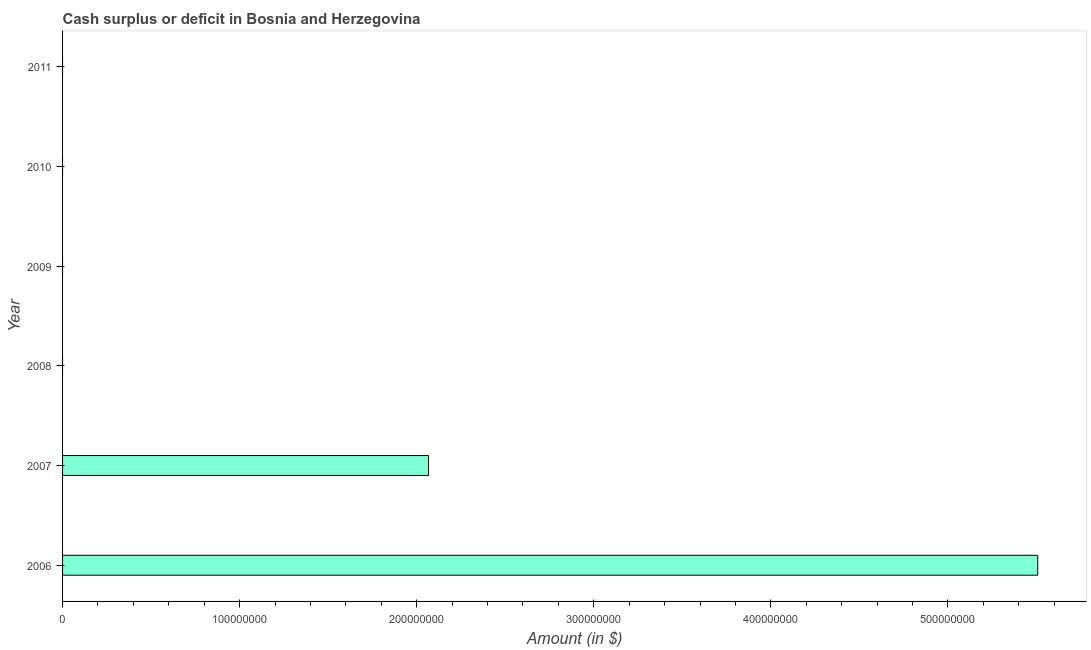Does the graph contain grids?
Offer a terse response. No. What is the title of the graph?
Your answer should be very brief. Cash surplus or deficit in Bosnia and Herzegovina. What is the label or title of the X-axis?
Make the answer very short. Amount (in $). What is the cash surplus or deficit in 2009?
Keep it short and to the point. 0. Across all years, what is the maximum cash surplus or deficit?
Your answer should be compact. 5.51e+08. Across all years, what is the minimum cash surplus or deficit?
Your response must be concise. 0. In which year was the cash surplus or deficit maximum?
Ensure brevity in your answer.  2006. What is the sum of the cash surplus or deficit?
Offer a very short reply. 7.57e+08. What is the average cash surplus or deficit per year?
Keep it short and to the point. 1.26e+08. What is the median cash surplus or deficit?
Give a very brief answer. 0. What is the difference between the highest and the lowest cash surplus or deficit?
Ensure brevity in your answer.  5.51e+08. In how many years, is the cash surplus or deficit greater than the average cash surplus or deficit taken over all years?
Ensure brevity in your answer.  2. How many bars are there?
Your response must be concise. 2. Are all the bars in the graph horizontal?
Provide a succinct answer. Yes. How many years are there in the graph?
Keep it short and to the point. 6. What is the difference between two consecutive major ticks on the X-axis?
Ensure brevity in your answer.  1.00e+08. What is the Amount (in $) of 2006?
Provide a short and direct response. 5.51e+08. What is the Amount (in $) in 2007?
Your response must be concise. 2.07e+08. What is the Amount (in $) in 2008?
Make the answer very short. 0. What is the Amount (in $) in 2010?
Give a very brief answer. 0. What is the difference between the Amount (in $) in 2006 and 2007?
Provide a succinct answer. 3.44e+08. What is the ratio of the Amount (in $) in 2006 to that in 2007?
Ensure brevity in your answer.  2.67. 